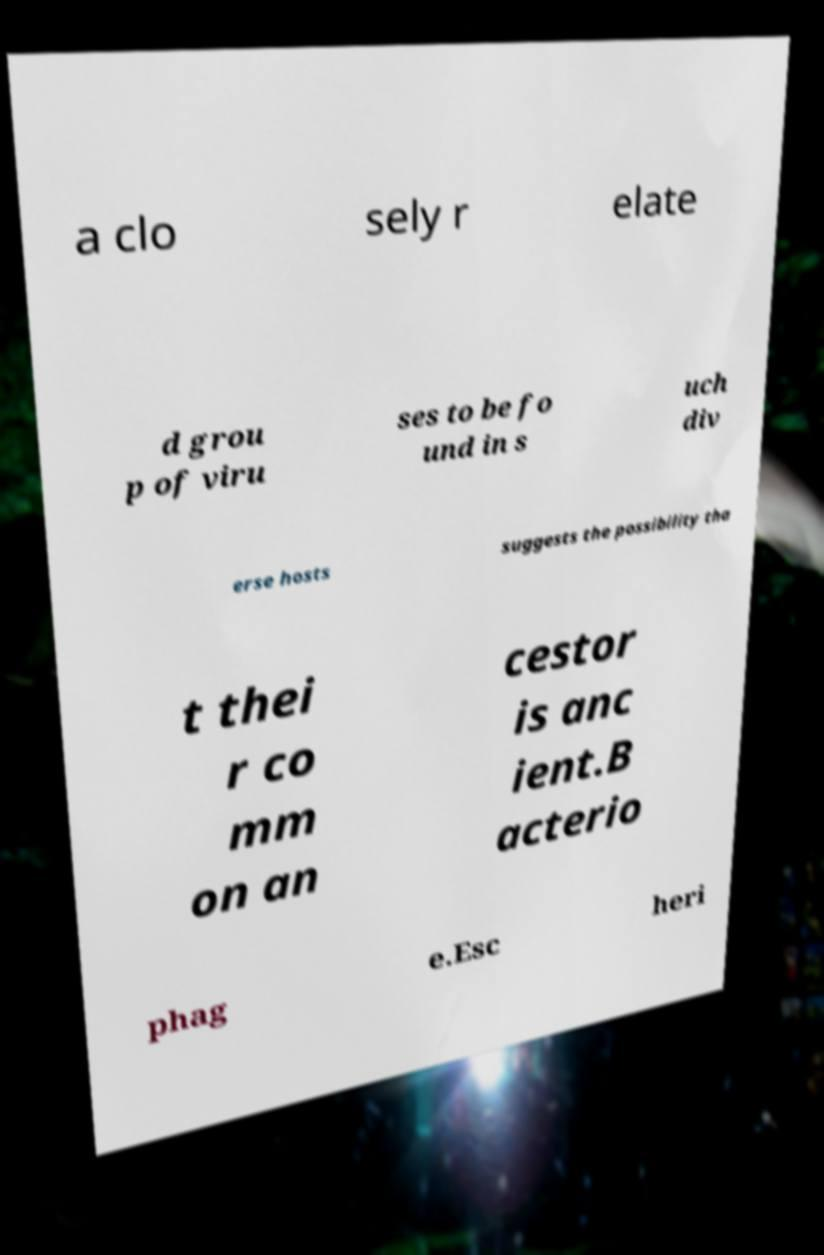Can you accurately transcribe the text from the provided image for me? a clo sely r elate d grou p of viru ses to be fo und in s uch div erse hosts suggests the possibility tha t thei r co mm on an cestor is anc ient.B acterio phag e.Esc heri 